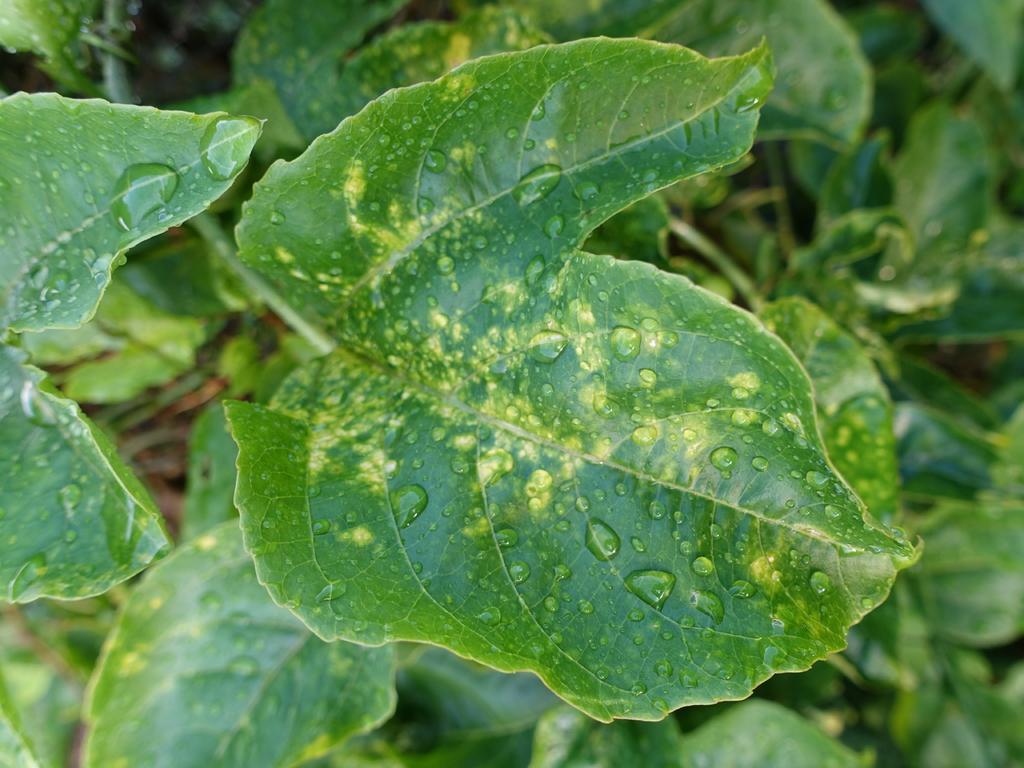Can you describe this image briefly? In the picture we can see the plant with many leaves, and on one leaf we can see water droplets. 